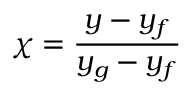Convert formula to latex. <formula><loc_0><loc_0><loc_500><loc_500>\chi = { \frac { y - y _ { f } } { y _ { g } - y _ { f } } }</formula> 